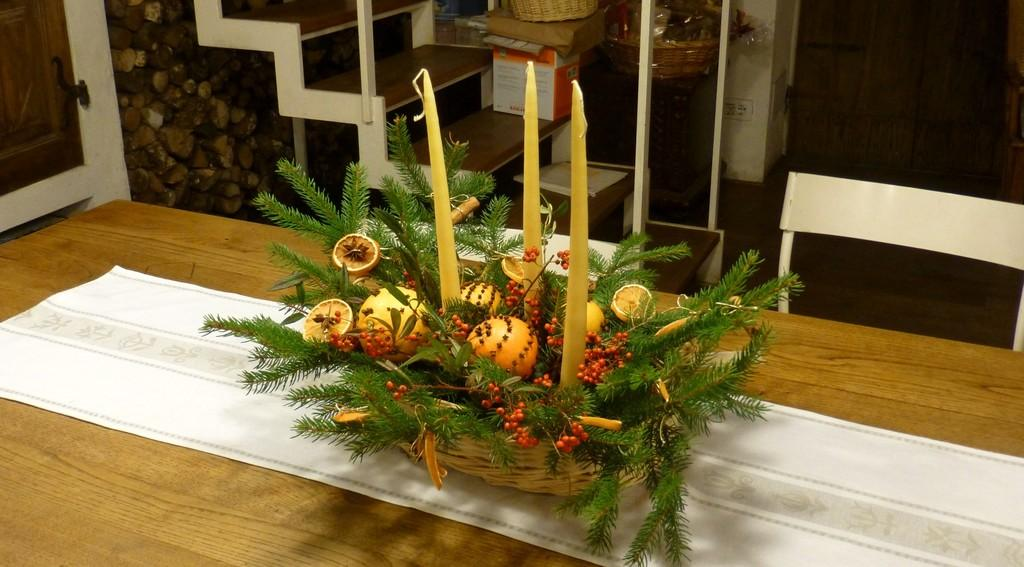What type of furniture is present in the image? There is a chair in the image. What is on the table in the image? There is a basket on the table in the image. What can be seen in the background of the image? There are boxes, another basket, and other unspecified objects visible in the background of the image. What material is used for the metal rods in the image? The metal rods in the image are made of metal. What historical event is depicted in the image? There is no historical event depicted in the image; it features a chair, a basket, boxes, and metal rods. What type of blade is used to cut the boxes in the image? There is no blade present in the image, and the boxes are not being cut. 